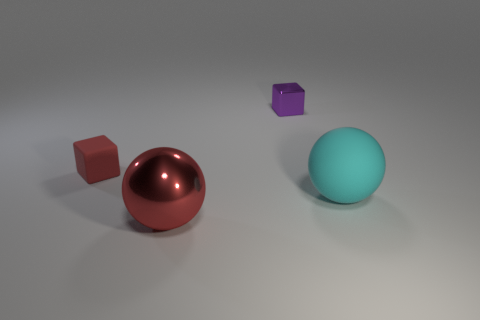There is a large object in front of the big cyan thing; is it the same color as the rubber block?
Offer a terse response. Yes. What is the cube on the right side of the shiny sphere made of?
Make the answer very short. Metal. The red matte thing that is the same size as the shiny cube is what shape?
Provide a succinct answer. Cube. Are there any cyan things that have the same shape as the purple shiny thing?
Your response must be concise. No. Are the cyan thing and the block that is left of the big metal sphere made of the same material?
Offer a terse response. Yes. What material is the block on the right side of the metallic object that is in front of the tiny matte object made of?
Provide a short and direct response. Metal. Are there more red objects that are behind the big red metal thing than tiny purple rubber blocks?
Offer a terse response. Yes. Are there any big balls?
Provide a succinct answer. Yes. The large thing in front of the big rubber thing is what color?
Provide a short and direct response. Red. There is a sphere that is the same size as the cyan thing; what is it made of?
Offer a very short reply. Metal. 